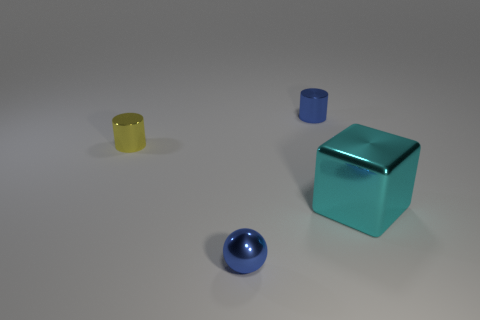Add 1 blue shiny balls. How many objects exist? 5 Subtract all cubes. How many objects are left? 3 Add 1 tiny yellow things. How many tiny yellow things exist? 2 Subtract 0 green blocks. How many objects are left? 4 Subtract all small purple balls. Subtract all metal cylinders. How many objects are left? 2 Add 3 blue shiny things. How many blue shiny things are left? 5 